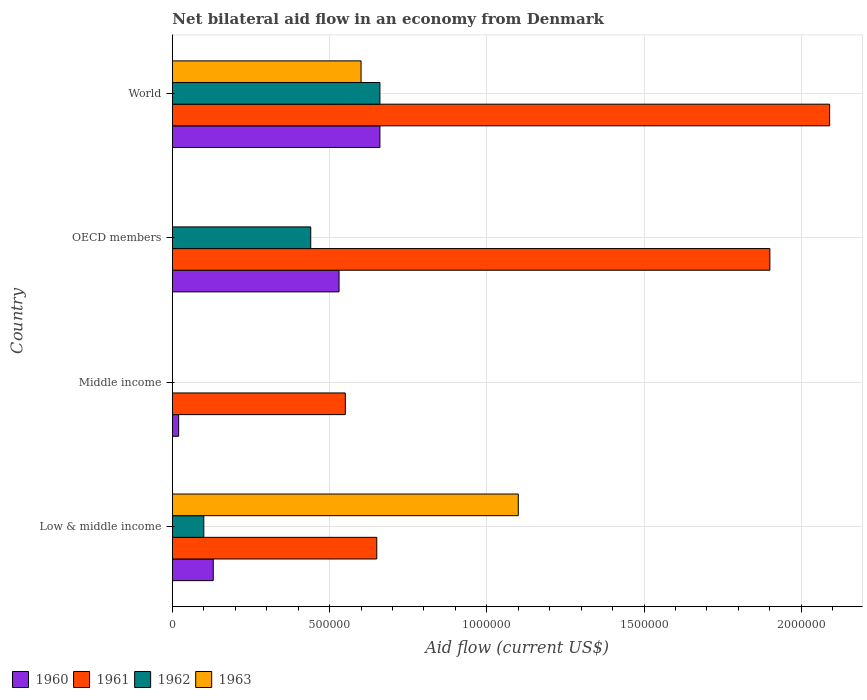How many different coloured bars are there?
Offer a very short reply. 4. How many groups of bars are there?
Make the answer very short. 4. Are the number of bars per tick equal to the number of legend labels?
Offer a very short reply. No. Are the number of bars on each tick of the Y-axis equal?
Your answer should be compact. No. What is the net bilateral aid flow in 1961 in Middle income?
Ensure brevity in your answer.  5.50e+05. What is the total net bilateral aid flow in 1963 in the graph?
Provide a succinct answer. 1.70e+06. What is the difference between the net bilateral aid flow in 1962 in OECD members and the net bilateral aid flow in 1960 in Middle income?
Give a very brief answer. 4.20e+05. What is the average net bilateral aid flow in 1963 per country?
Your answer should be compact. 4.25e+05. What is the difference between the net bilateral aid flow in 1960 and net bilateral aid flow in 1961 in Middle income?
Your response must be concise. -5.30e+05. In how many countries, is the net bilateral aid flow in 1960 greater than 1200000 US$?
Offer a terse response. 0. What is the ratio of the net bilateral aid flow in 1961 in Middle income to that in World?
Your response must be concise. 0.26. Is the difference between the net bilateral aid flow in 1960 in Middle income and OECD members greater than the difference between the net bilateral aid flow in 1961 in Middle income and OECD members?
Offer a very short reply. Yes. What is the difference between the highest and the second highest net bilateral aid flow in 1962?
Offer a very short reply. 2.20e+05. What is the difference between the highest and the lowest net bilateral aid flow in 1963?
Make the answer very short. 1.10e+06. In how many countries, is the net bilateral aid flow in 1960 greater than the average net bilateral aid flow in 1960 taken over all countries?
Make the answer very short. 2. Is the sum of the net bilateral aid flow in 1961 in Middle income and OECD members greater than the maximum net bilateral aid flow in 1960 across all countries?
Provide a short and direct response. Yes. Is it the case that in every country, the sum of the net bilateral aid flow in 1963 and net bilateral aid flow in 1961 is greater than the net bilateral aid flow in 1960?
Keep it short and to the point. Yes. Are the values on the major ticks of X-axis written in scientific E-notation?
Give a very brief answer. No. How many legend labels are there?
Provide a short and direct response. 4. What is the title of the graph?
Give a very brief answer. Net bilateral aid flow in an economy from Denmark. Does "2010" appear as one of the legend labels in the graph?
Provide a succinct answer. No. What is the label or title of the X-axis?
Ensure brevity in your answer.  Aid flow (current US$). What is the Aid flow (current US$) in 1961 in Low & middle income?
Offer a very short reply. 6.50e+05. What is the Aid flow (current US$) of 1962 in Low & middle income?
Your answer should be very brief. 1.00e+05. What is the Aid flow (current US$) in 1963 in Low & middle income?
Offer a terse response. 1.10e+06. What is the Aid flow (current US$) in 1960 in Middle income?
Your response must be concise. 2.00e+04. What is the Aid flow (current US$) in 1961 in Middle income?
Provide a succinct answer. 5.50e+05. What is the Aid flow (current US$) in 1962 in Middle income?
Your answer should be compact. 0. What is the Aid flow (current US$) in 1960 in OECD members?
Provide a succinct answer. 5.30e+05. What is the Aid flow (current US$) of 1961 in OECD members?
Your response must be concise. 1.90e+06. What is the Aid flow (current US$) in 1962 in OECD members?
Your answer should be very brief. 4.40e+05. What is the Aid flow (current US$) in 1963 in OECD members?
Provide a short and direct response. 0. What is the Aid flow (current US$) in 1961 in World?
Your response must be concise. 2.09e+06. What is the Aid flow (current US$) in 1962 in World?
Provide a short and direct response. 6.60e+05. What is the Aid flow (current US$) in 1963 in World?
Give a very brief answer. 6.00e+05. Across all countries, what is the maximum Aid flow (current US$) in 1961?
Keep it short and to the point. 2.09e+06. Across all countries, what is the maximum Aid flow (current US$) in 1963?
Offer a very short reply. 1.10e+06. Across all countries, what is the minimum Aid flow (current US$) of 1963?
Provide a succinct answer. 0. What is the total Aid flow (current US$) of 1960 in the graph?
Provide a succinct answer. 1.34e+06. What is the total Aid flow (current US$) in 1961 in the graph?
Make the answer very short. 5.19e+06. What is the total Aid flow (current US$) of 1962 in the graph?
Offer a terse response. 1.20e+06. What is the total Aid flow (current US$) of 1963 in the graph?
Offer a terse response. 1.70e+06. What is the difference between the Aid flow (current US$) of 1960 in Low & middle income and that in OECD members?
Your answer should be very brief. -4.00e+05. What is the difference between the Aid flow (current US$) of 1961 in Low & middle income and that in OECD members?
Offer a very short reply. -1.25e+06. What is the difference between the Aid flow (current US$) in 1960 in Low & middle income and that in World?
Provide a succinct answer. -5.30e+05. What is the difference between the Aid flow (current US$) in 1961 in Low & middle income and that in World?
Ensure brevity in your answer.  -1.44e+06. What is the difference between the Aid flow (current US$) in 1962 in Low & middle income and that in World?
Your response must be concise. -5.60e+05. What is the difference between the Aid flow (current US$) in 1960 in Middle income and that in OECD members?
Offer a terse response. -5.10e+05. What is the difference between the Aid flow (current US$) of 1961 in Middle income and that in OECD members?
Ensure brevity in your answer.  -1.35e+06. What is the difference between the Aid flow (current US$) in 1960 in Middle income and that in World?
Offer a very short reply. -6.40e+05. What is the difference between the Aid flow (current US$) in 1961 in Middle income and that in World?
Offer a very short reply. -1.54e+06. What is the difference between the Aid flow (current US$) of 1961 in OECD members and that in World?
Provide a short and direct response. -1.90e+05. What is the difference between the Aid flow (current US$) of 1962 in OECD members and that in World?
Provide a short and direct response. -2.20e+05. What is the difference between the Aid flow (current US$) of 1960 in Low & middle income and the Aid flow (current US$) of 1961 in Middle income?
Your answer should be compact. -4.20e+05. What is the difference between the Aid flow (current US$) of 1960 in Low & middle income and the Aid flow (current US$) of 1961 in OECD members?
Keep it short and to the point. -1.77e+06. What is the difference between the Aid flow (current US$) in 1960 in Low & middle income and the Aid flow (current US$) in 1962 in OECD members?
Ensure brevity in your answer.  -3.10e+05. What is the difference between the Aid flow (current US$) of 1960 in Low & middle income and the Aid flow (current US$) of 1961 in World?
Offer a very short reply. -1.96e+06. What is the difference between the Aid flow (current US$) in 1960 in Low & middle income and the Aid flow (current US$) in 1962 in World?
Your answer should be compact. -5.30e+05. What is the difference between the Aid flow (current US$) in 1960 in Low & middle income and the Aid flow (current US$) in 1963 in World?
Provide a succinct answer. -4.70e+05. What is the difference between the Aid flow (current US$) in 1961 in Low & middle income and the Aid flow (current US$) in 1963 in World?
Offer a terse response. 5.00e+04. What is the difference between the Aid flow (current US$) of 1962 in Low & middle income and the Aid flow (current US$) of 1963 in World?
Keep it short and to the point. -5.00e+05. What is the difference between the Aid flow (current US$) in 1960 in Middle income and the Aid flow (current US$) in 1961 in OECD members?
Offer a terse response. -1.88e+06. What is the difference between the Aid flow (current US$) of 1960 in Middle income and the Aid flow (current US$) of 1962 in OECD members?
Offer a very short reply. -4.20e+05. What is the difference between the Aid flow (current US$) of 1960 in Middle income and the Aid flow (current US$) of 1961 in World?
Your answer should be compact. -2.07e+06. What is the difference between the Aid flow (current US$) of 1960 in Middle income and the Aid flow (current US$) of 1962 in World?
Give a very brief answer. -6.40e+05. What is the difference between the Aid flow (current US$) in 1960 in Middle income and the Aid flow (current US$) in 1963 in World?
Provide a short and direct response. -5.80e+05. What is the difference between the Aid flow (current US$) in 1961 in Middle income and the Aid flow (current US$) in 1962 in World?
Provide a short and direct response. -1.10e+05. What is the difference between the Aid flow (current US$) of 1961 in Middle income and the Aid flow (current US$) of 1963 in World?
Offer a terse response. -5.00e+04. What is the difference between the Aid flow (current US$) in 1960 in OECD members and the Aid flow (current US$) in 1961 in World?
Make the answer very short. -1.56e+06. What is the difference between the Aid flow (current US$) of 1961 in OECD members and the Aid flow (current US$) of 1962 in World?
Offer a very short reply. 1.24e+06. What is the difference between the Aid flow (current US$) in 1961 in OECD members and the Aid flow (current US$) in 1963 in World?
Give a very brief answer. 1.30e+06. What is the difference between the Aid flow (current US$) of 1962 in OECD members and the Aid flow (current US$) of 1963 in World?
Ensure brevity in your answer.  -1.60e+05. What is the average Aid flow (current US$) of 1960 per country?
Ensure brevity in your answer.  3.35e+05. What is the average Aid flow (current US$) of 1961 per country?
Give a very brief answer. 1.30e+06. What is the average Aid flow (current US$) in 1963 per country?
Give a very brief answer. 4.25e+05. What is the difference between the Aid flow (current US$) of 1960 and Aid flow (current US$) of 1961 in Low & middle income?
Offer a very short reply. -5.20e+05. What is the difference between the Aid flow (current US$) in 1960 and Aid flow (current US$) in 1963 in Low & middle income?
Provide a succinct answer. -9.70e+05. What is the difference between the Aid flow (current US$) of 1961 and Aid flow (current US$) of 1963 in Low & middle income?
Make the answer very short. -4.50e+05. What is the difference between the Aid flow (current US$) of 1960 and Aid flow (current US$) of 1961 in Middle income?
Make the answer very short. -5.30e+05. What is the difference between the Aid flow (current US$) of 1960 and Aid flow (current US$) of 1961 in OECD members?
Provide a short and direct response. -1.37e+06. What is the difference between the Aid flow (current US$) in 1960 and Aid flow (current US$) in 1962 in OECD members?
Your answer should be compact. 9.00e+04. What is the difference between the Aid flow (current US$) in 1961 and Aid flow (current US$) in 1962 in OECD members?
Offer a very short reply. 1.46e+06. What is the difference between the Aid flow (current US$) of 1960 and Aid flow (current US$) of 1961 in World?
Provide a succinct answer. -1.43e+06. What is the difference between the Aid flow (current US$) in 1960 and Aid flow (current US$) in 1962 in World?
Provide a succinct answer. 0. What is the difference between the Aid flow (current US$) of 1961 and Aid flow (current US$) of 1962 in World?
Provide a short and direct response. 1.43e+06. What is the difference between the Aid flow (current US$) of 1961 and Aid flow (current US$) of 1963 in World?
Provide a succinct answer. 1.49e+06. What is the difference between the Aid flow (current US$) of 1962 and Aid flow (current US$) of 1963 in World?
Provide a succinct answer. 6.00e+04. What is the ratio of the Aid flow (current US$) of 1960 in Low & middle income to that in Middle income?
Ensure brevity in your answer.  6.5. What is the ratio of the Aid flow (current US$) in 1961 in Low & middle income to that in Middle income?
Ensure brevity in your answer.  1.18. What is the ratio of the Aid flow (current US$) in 1960 in Low & middle income to that in OECD members?
Your response must be concise. 0.25. What is the ratio of the Aid flow (current US$) of 1961 in Low & middle income to that in OECD members?
Provide a succinct answer. 0.34. What is the ratio of the Aid flow (current US$) of 1962 in Low & middle income to that in OECD members?
Your answer should be compact. 0.23. What is the ratio of the Aid flow (current US$) of 1960 in Low & middle income to that in World?
Keep it short and to the point. 0.2. What is the ratio of the Aid flow (current US$) of 1961 in Low & middle income to that in World?
Provide a short and direct response. 0.31. What is the ratio of the Aid flow (current US$) of 1962 in Low & middle income to that in World?
Provide a short and direct response. 0.15. What is the ratio of the Aid flow (current US$) of 1963 in Low & middle income to that in World?
Offer a terse response. 1.83. What is the ratio of the Aid flow (current US$) in 1960 in Middle income to that in OECD members?
Your answer should be compact. 0.04. What is the ratio of the Aid flow (current US$) in 1961 in Middle income to that in OECD members?
Offer a terse response. 0.29. What is the ratio of the Aid flow (current US$) in 1960 in Middle income to that in World?
Provide a succinct answer. 0.03. What is the ratio of the Aid flow (current US$) in 1961 in Middle income to that in World?
Ensure brevity in your answer.  0.26. What is the ratio of the Aid flow (current US$) in 1960 in OECD members to that in World?
Ensure brevity in your answer.  0.8. What is the ratio of the Aid flow (current US$) of 1961 in OECD members to that in World?
Make the answer very short. 0.91. What is the ratio of the Aid flow (current US$) in 1962 in OECD members to that in World?
Offer a terse response. 0.67. What is the difference between the highest and the second highest Aid flow (current US$) in 1962?
Keep it short and to the point. 2.20e+05. What is the difference between the highest and the lowest Aid flow (current US$) of 1960?
Provide a succinct answer. 6.40e+05. What is the difference between the highest and the lowest Aid flow (current US$) of 1961?
Your answer should be compact. 1.54e+06. What is the difference between the highest and the lowest Aid flow (current US$) of 1963?
Your response must be concise. 1.10e+06. 